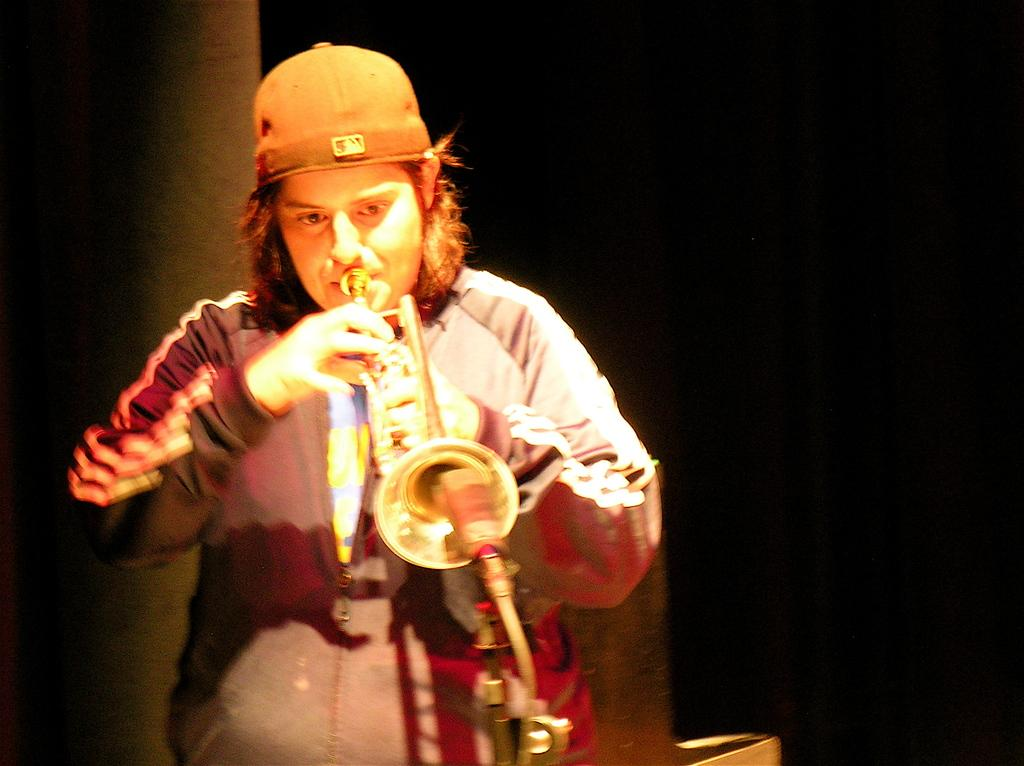What is the main subject on the left side of the image? There is a person on the left side of the image. What is the person wearing on their head? The person is wearing a cap. What activity is the person engaged in? The person is playing a musical instrument. What is the person's posture in the image? The person is standing. How would you describe the background of the image? The background of the image is dark in color. How many bikes are parked next to the person in the image? There are no bikes visible in the image. What type of zipper can be seen on the person's clothing in the image? There is no zipper visible on the person's clothing in the image. 